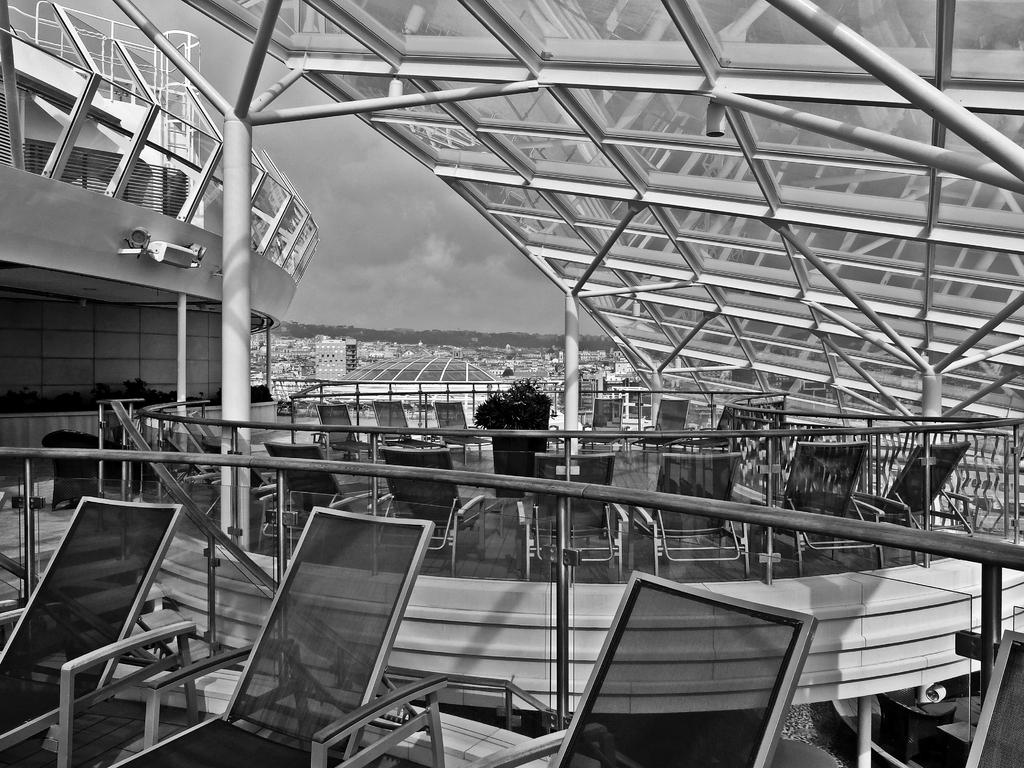What type of furniture is present in the image? There are chairs in the image. What can be seen near the chairs? There is a railing in the image. What type of greenery is in the image? There is a plant in the image. What can be seen in the distance in the image? There are buildings, trees, and clouds in the background of the image. What part of the natural environment is visible in the image? The sky is visible in the background of the image. How many fish can be seen swimming in the image? There are no fish present in the image. What type of fingerprint can be seen on the railing in the image? There is no fingerprint visible on the railing in the image. 